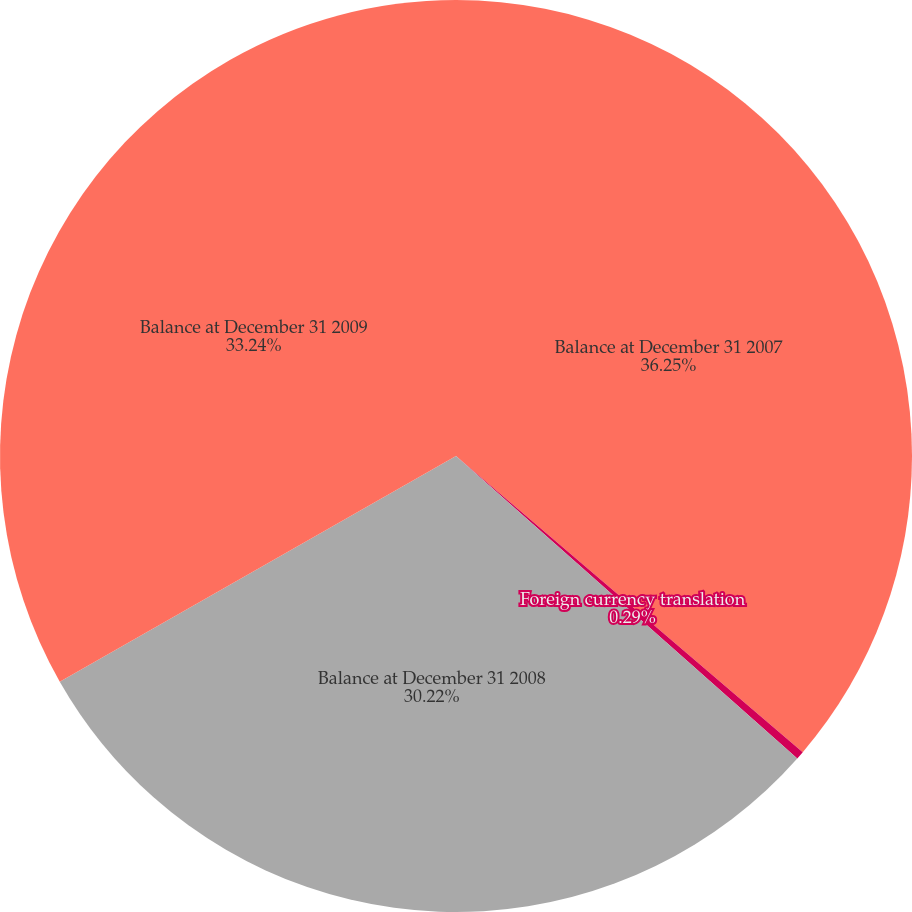Convert chart to OTSL. <chart><loc_0><loc_0><loc_500><loc_500><pie_chart><fcel>Balance at December 31 2007<fcel>Foreign currency translation<fcel>Balance at December 31 2008<fcel>Balance at December 31 2009<nl><fcel>36.25%<fcel>0.29%<fcel>30.22%<fcel>33.24%<nl></chart> 